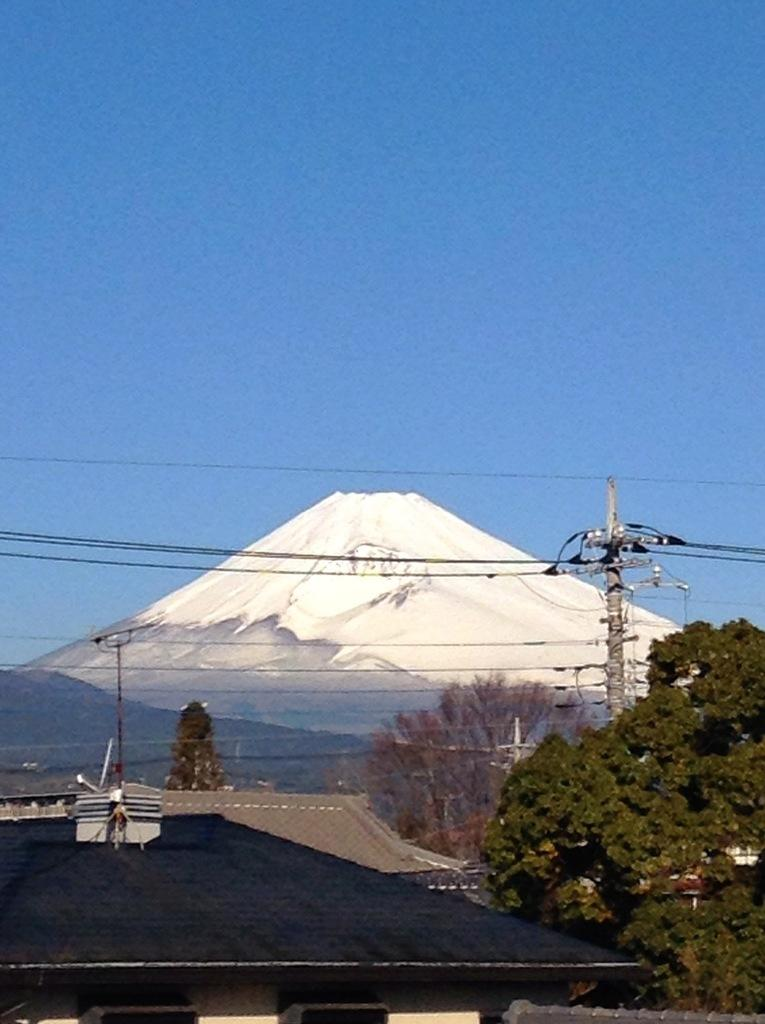What type of structures can be seen in the image? There are buildings in the image. What natural elements are present in the image? There are trees and mountains in the image. What additional information is displayed in the image? There are current polls in the image. What part of the natural environment is visible in the image? The sky is visible in the image. Where is the volleyball located in the image? There is no volleyball present in the image. What type of shelf can be seen in the image? There is no shelf present in the image. 